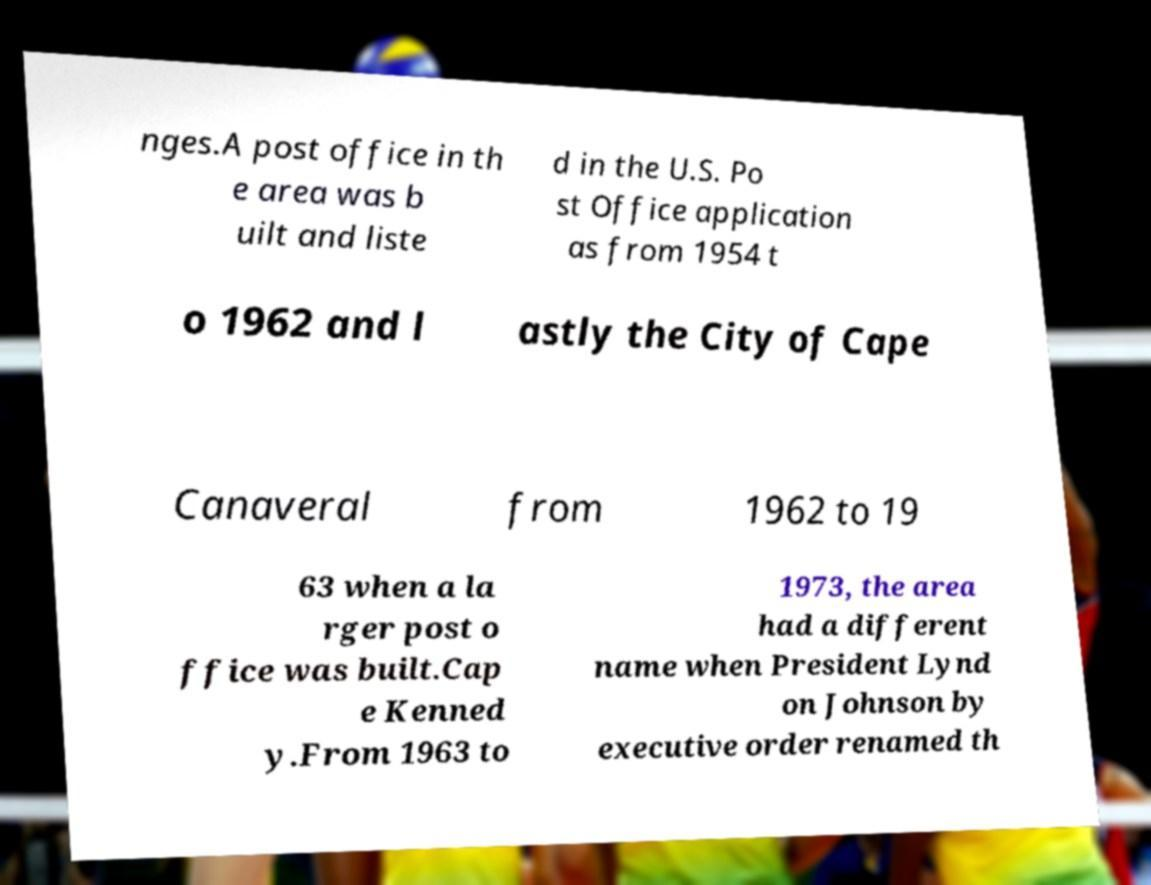Can you read and provide the text displayed in the image?This photo seems to have some interesting text. Can you extract and type it out for me? nges.A post office in th e area was b uilt and liste d in the U.S. Po st Office application as from 1954 t o 1962 and l astly the City of Cape Canaveral from 1962 to 19 63 when a la rger post o ffice was built.Cap e Kenned y.From 1963 to 1973, the area had a different name when President Lynd on Johnson by executive order renamed th 